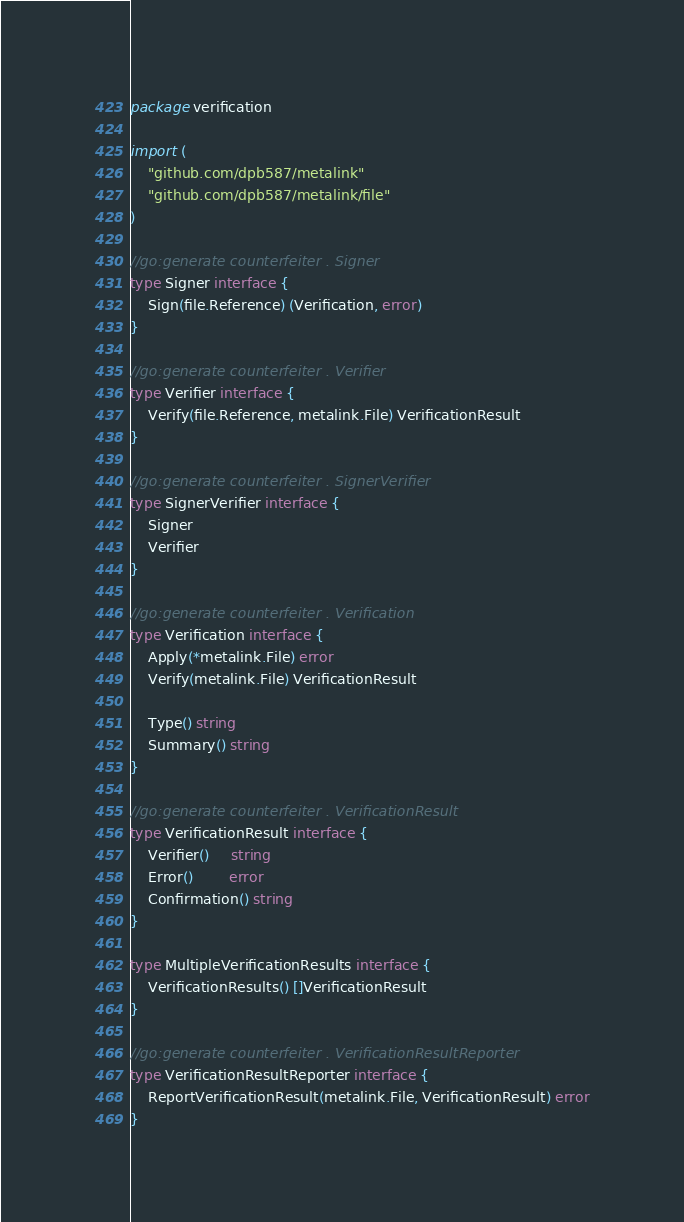Convert code to text. <code><loc_0><loc_0><loc_500><loc_500><_Go_>package verification

import (
	"github.com/dpb587/metalink"
	"github.com/dpb587/metalink/file"
)

//go:generate counterfeiter . Signer
type Signer interface {
	Sign(file.Reference) (Verification, error)
}

//go:generate counterfeiter . Verifier
type Verifier interface {
	Verify(file.Reference, metalink.File) VerificationResult
}

//go:generate counterfeiter . SignerVerifier
type SignerVerifier interface {
	Signer
	Verifier
}

//go:generate counterfeiter . Verification
type Verification interface {
	Apply(*metalink.File) error
	Verify(metalink.File) VerificationResult

	Type() string
	Summary() string
}

//go:generate counterfeiter . VerificationResult
type VerificationResult interface {
	Verifier()     string
	Error()        error
	Confirmation() string
}

type MultipleVerificationResults interface {
	VerificationResults() []VerificationResult
}

//go:generate counterfeiter . VerificationResultReporter
type VerificationResultReporter interface {
	ReportVerificationResult(metalink.File, VerificationResult) error
}
</code> 